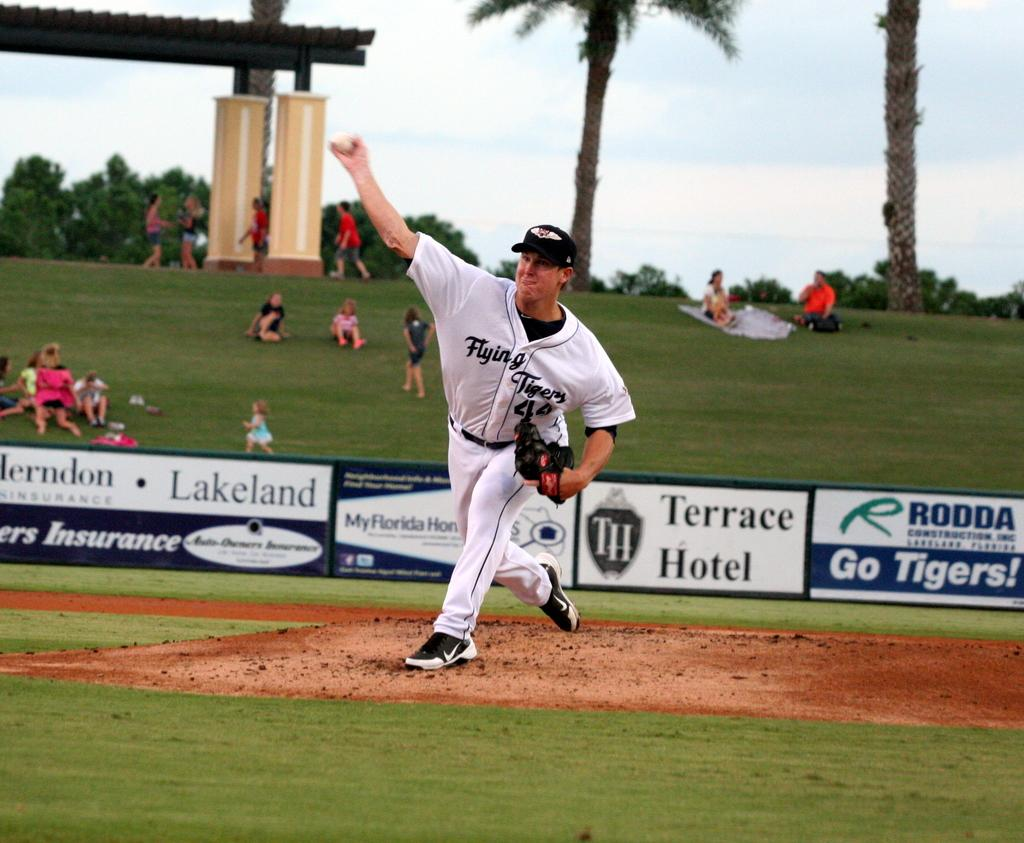<image>
Present a compact description of the photo's key features. A man stands in front of an advert for Terrace Hotel and throws a ball. 